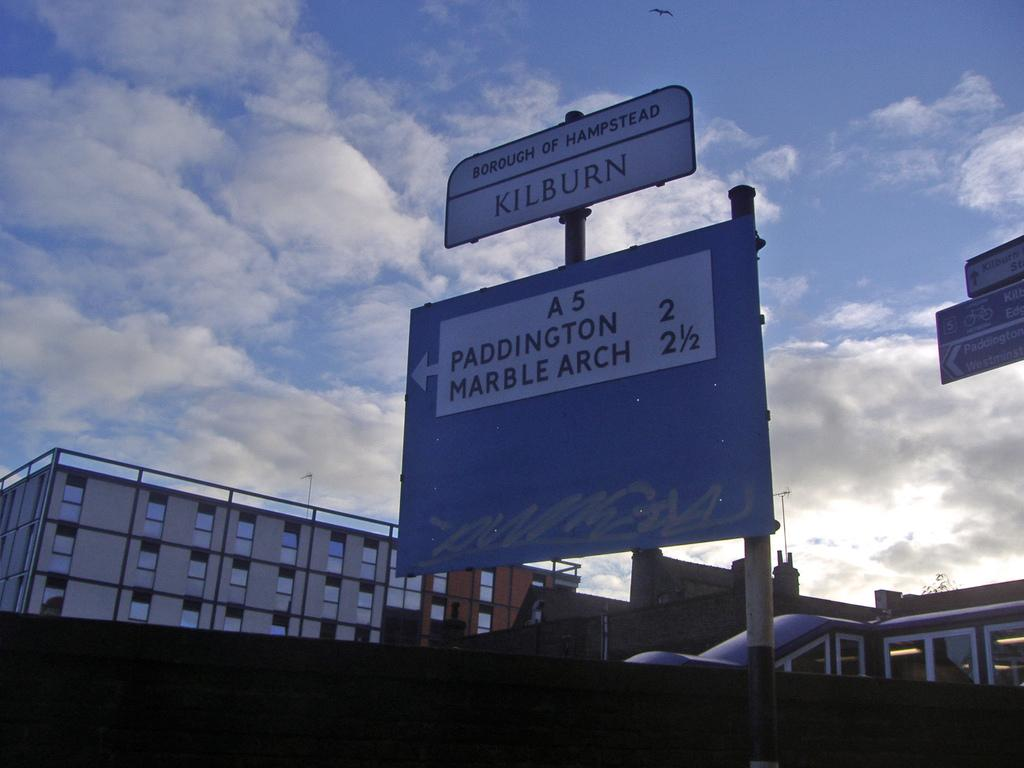<image>
Describe the image concisely. A sign post for Kilburn displaying how far away the Marble Arch is. 